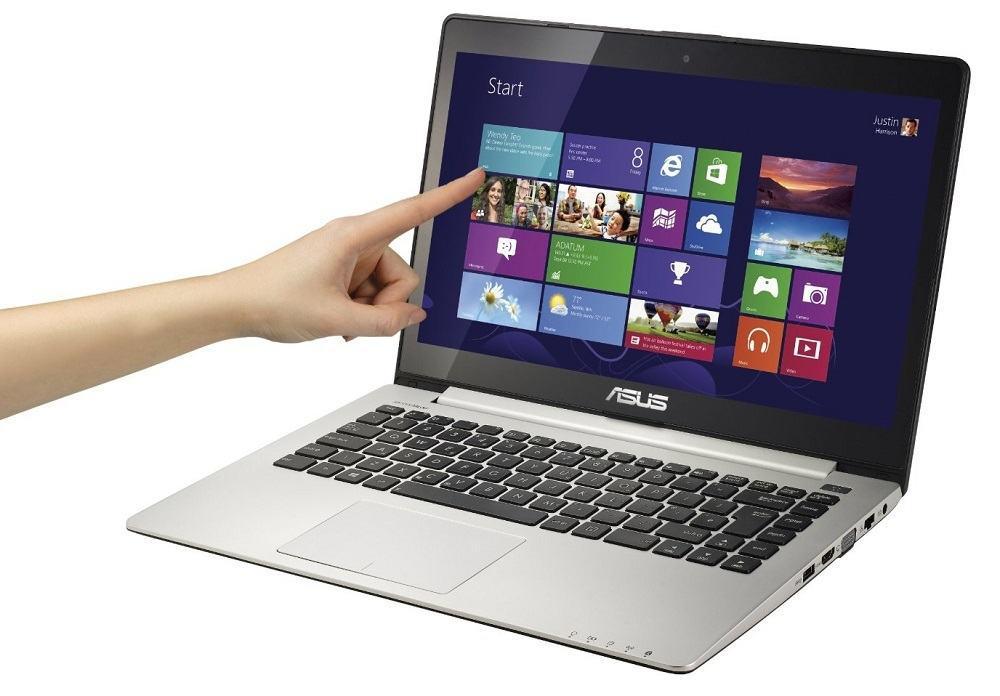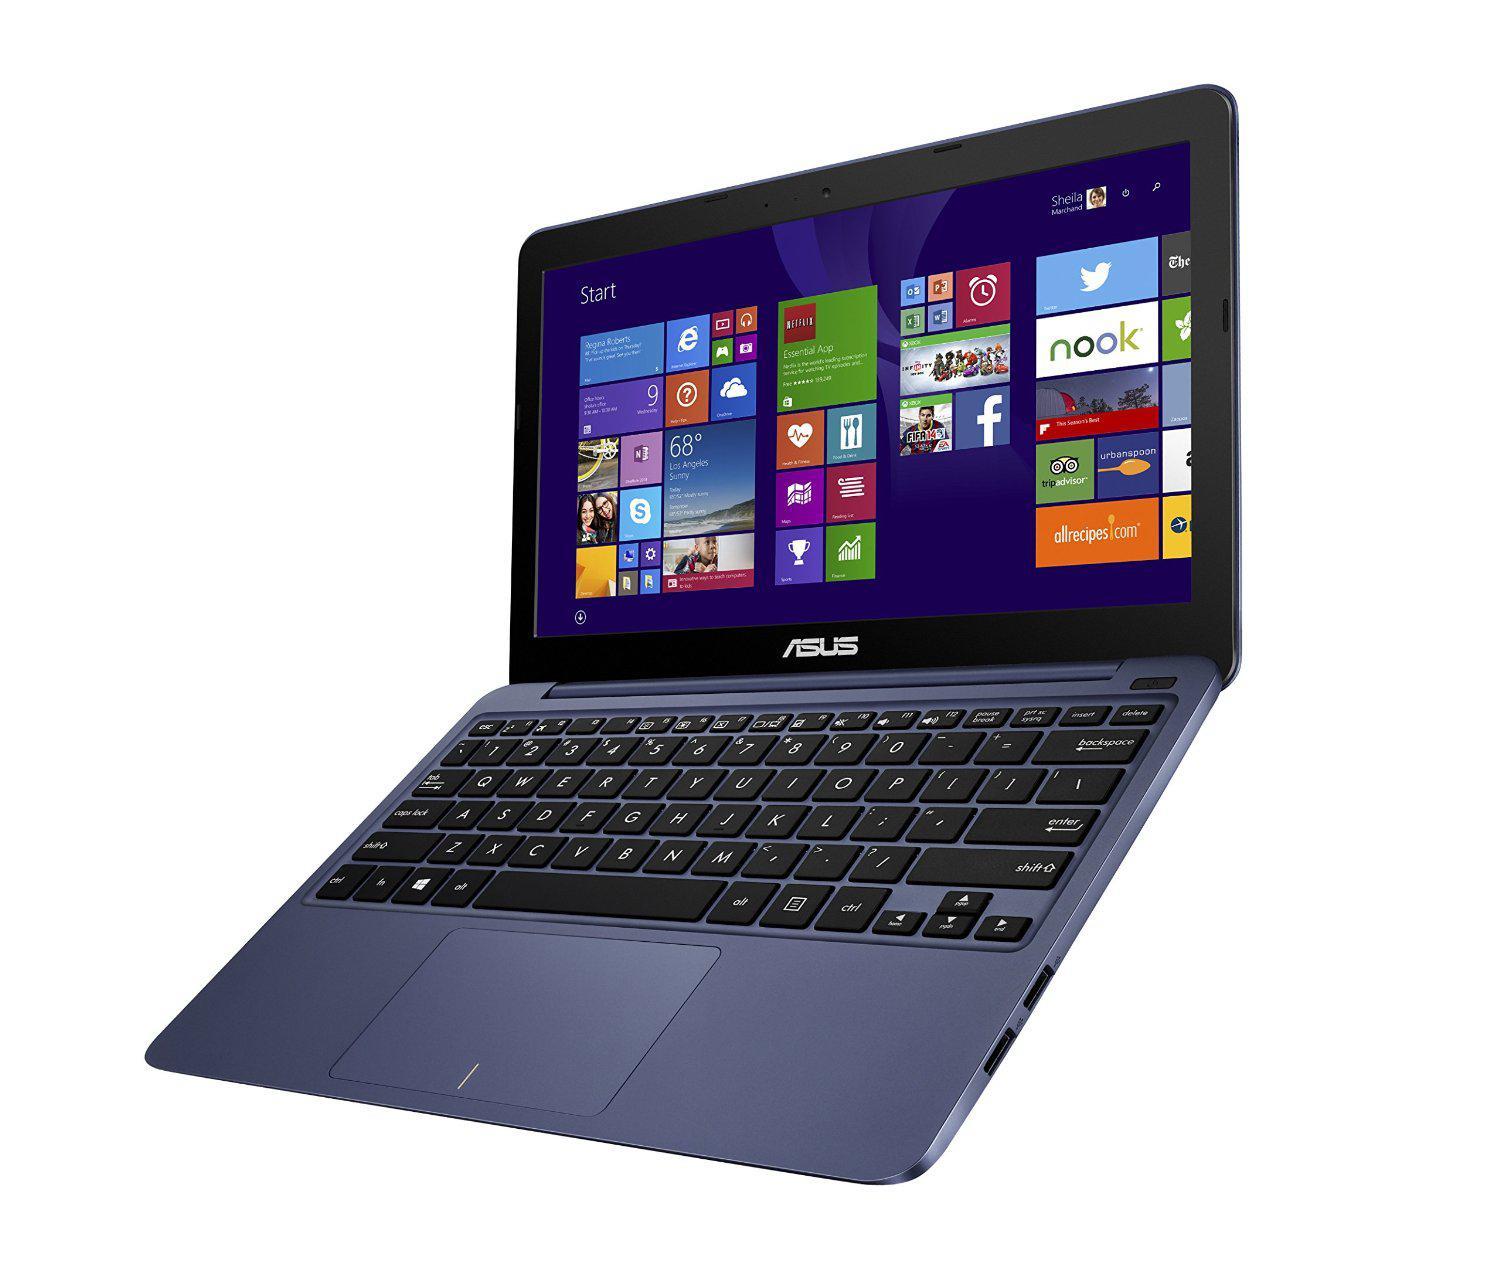The first image is the image on the left, the second image is the image on the right. Given the left and right images, does the statement "There are two computers in total." hold true? Answer yes or no. Yes. The first image is the image on the left, the second image is the image on the right. Evaluate the accuracy of this statement regarding the images: "A finger is pointing to an open laptop screen displaying a grid of rectangles and squares in the left image.". Is it true? Answer yes or no. Yes. 